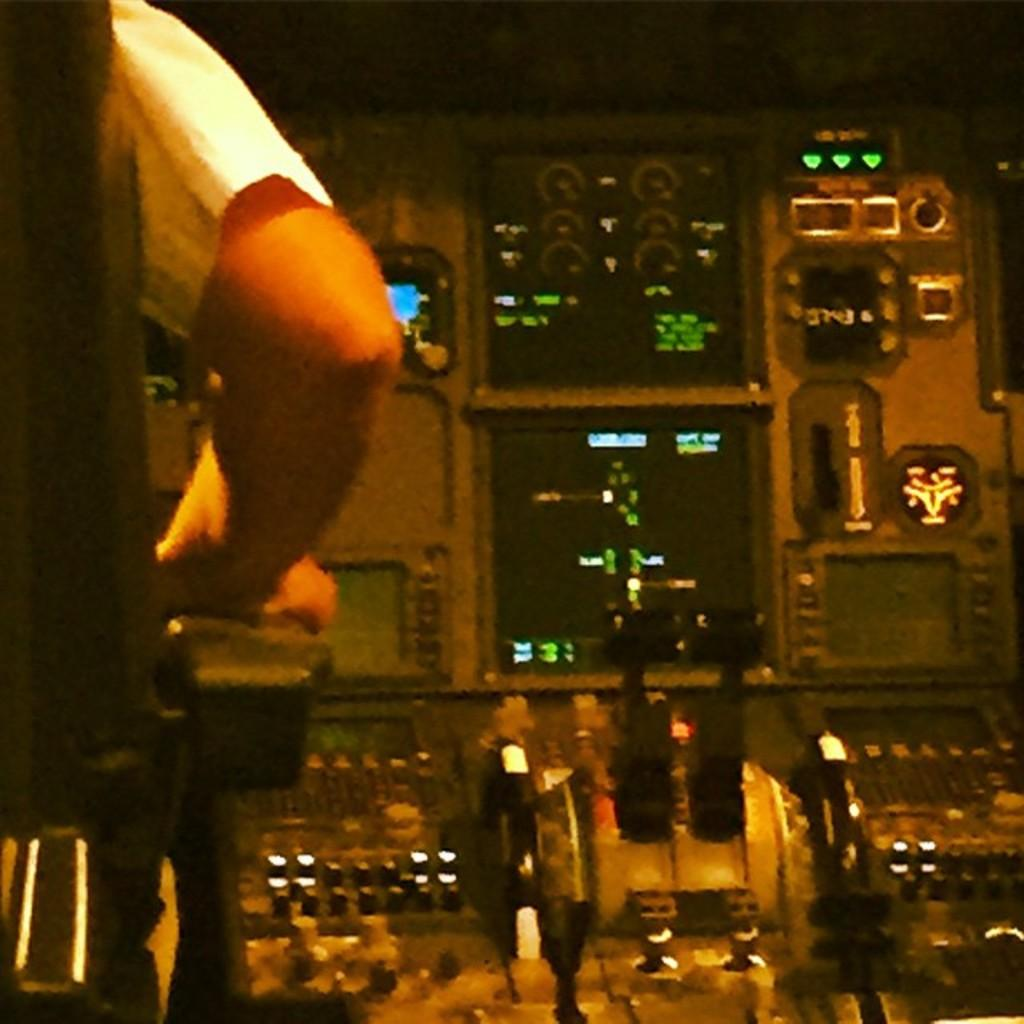What part of a person can be seen in the image? There is a person's hand in the image. What type of furniture is present in the image? There is a chair in the image. What type of electronic devices are visible in the image? There are screens in the image. What type of interactive elements are present in the image? There are buttons in the image. What type of crate is being used for digestion in the image? There is no crate or reference to digestion present in the image. 